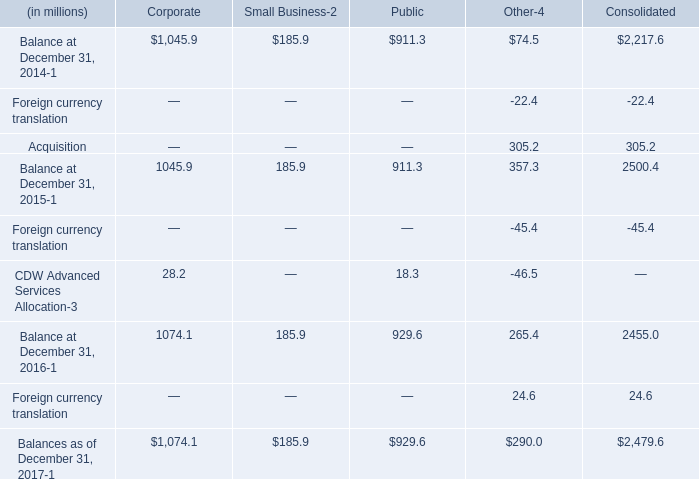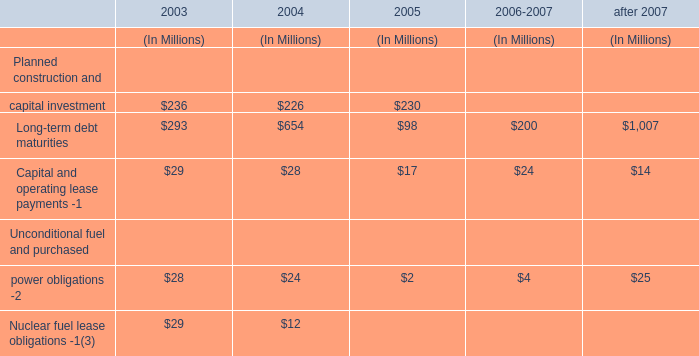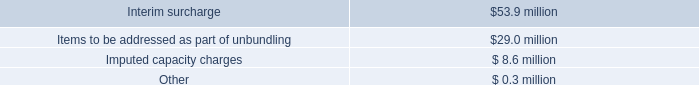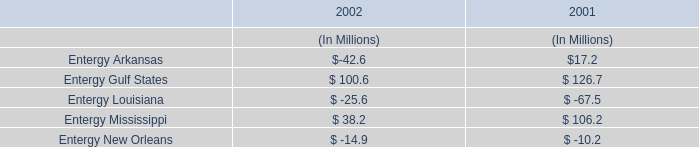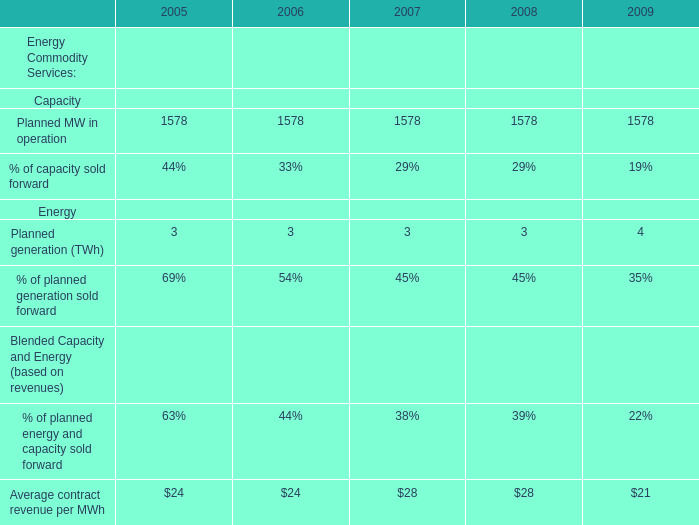What's the growth rate of Planned generation (TWh) in 2009? 
Computations: ((4 - 3) / 3)
Answer: 0.33333. 